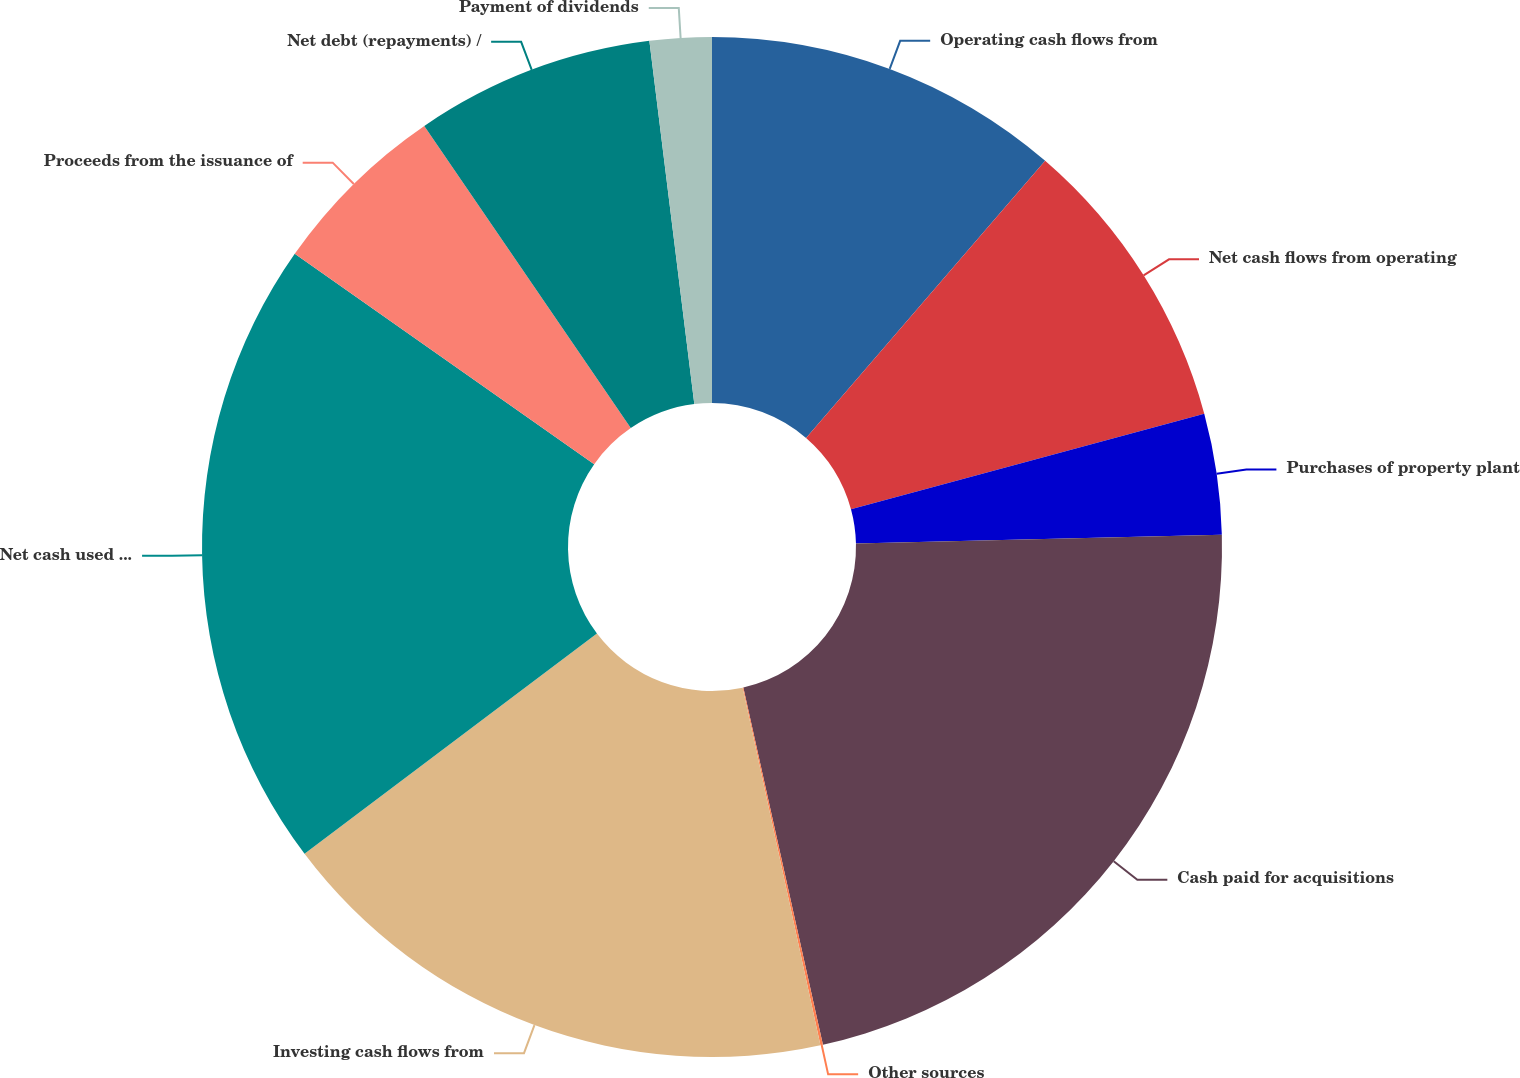<chart> <loc_0><loc_0><loc_500><loc_500><pie_chart><fcel>Operating cash flows from<fcel>Net cash flows from operating<fcel>Purchases of property plant<fcel>Cash paid for acquisitions<fcel>Other sources<fcel>Investing cash flows from<fcel>Net cash used in investing<fcel>Proceeds from the issuance of<fcel>Net debt (repayments) /<fcel>Payment of dividends<nl><fcel>11.33%<fcel>9.46%<fcel>3.83%<fcel>21.89%<fcel>0.08%<fcel>18.14%<fcel>20.02%<fcel>5.71%<fcel>7.58%<fcel>1.96%<nl></chart> 